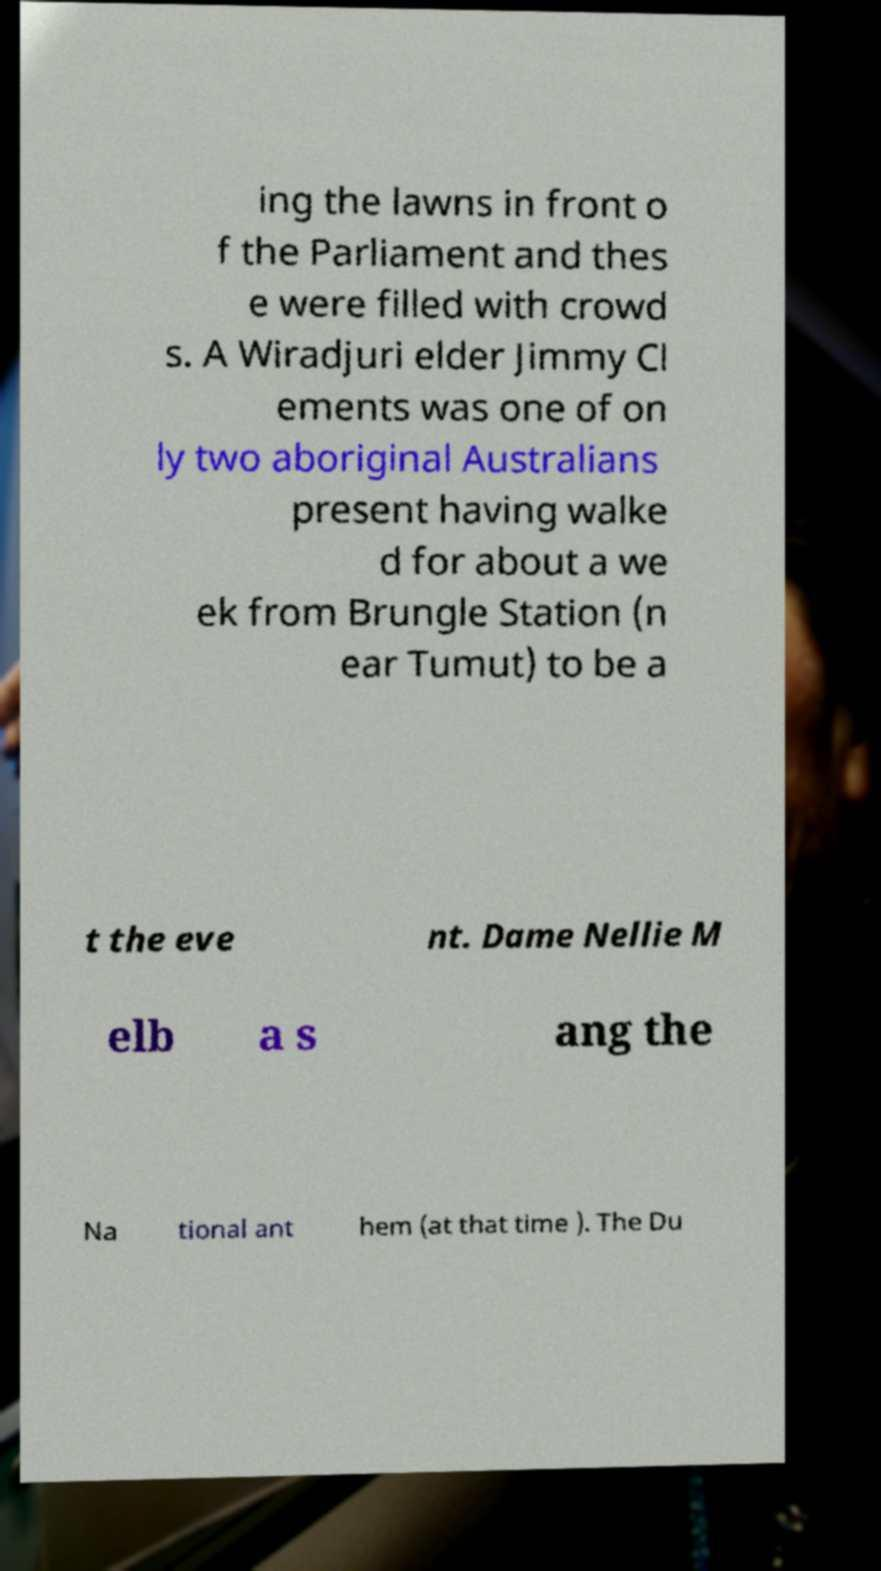Could you assist in decoding the text presented in this image and type it out clearly? ing the lawns in front o f the Parliament and thes e were filled with crowd s. A Wiradjuri elder Jimmy Cl ements was one of on ly two aboriginal Australians present having walke d for about a we ek from Brungle Station (n ear Tumut) to be a t the eve nt. Dame Nellie M elb a s ang the Na tional ant hem (at that time ). The Du 